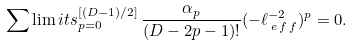Convert formula to latex. <formula><loc_0><loc_0><loc_500><loc_500>\sum \lim i t s _ { p = 0 } ^ { [ ( D - 1 ) / 2 ] } \, \frac { \alpha _ { p } } { ( D - 2 p - 1 ) ! } ( - \ell _ { \, e \, f \, f } ^ { - 2 } ) ^ { p } = 0 .</formula> 